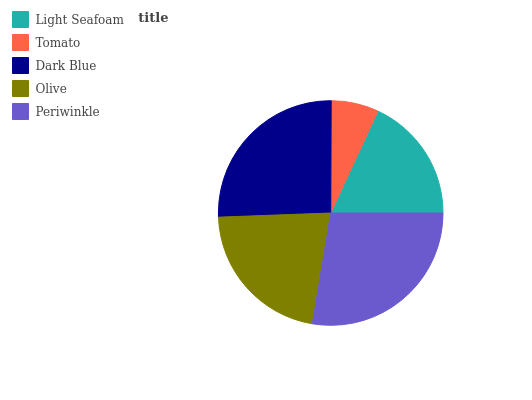Is Tomato the minimum?
Answer yes or no. Yes. Is Periwinkle the maximum?
Answer yes or no. Yes. Is Dark Blue the minimum?
Answer yes or no. No. Is Dark Blue the maximum?
Answer yes or no. No. Is Dark Blue greater than Tomato?
Answer yes or no. Yes. Is Tomato less than Dark Blue?
Answer yes or no. Yes. Is Tomato greater than Dark Blue?
Answer yes or no. No. Is Dark Blue less than Tomato?
Answer yes or no. No. Is Olive the high median?
Answer yes or no. Yes. Is Olive the low median?
Answer yes or no. Yes. Is Light Seafoam the high median?
Answer yes or no. No. Is Periwinkle the low median?
Answer yes or no. No. 